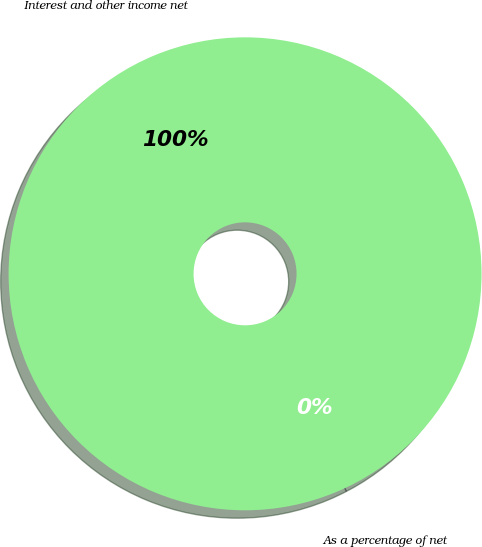<chart> <loc_0><loc_0><loc_500><loc_500><pie_chart><fcel>Interest and other income net<fcel>As a percentage of net<nl><fcel>100.0%<fcel>0.0%<nl></chart> 